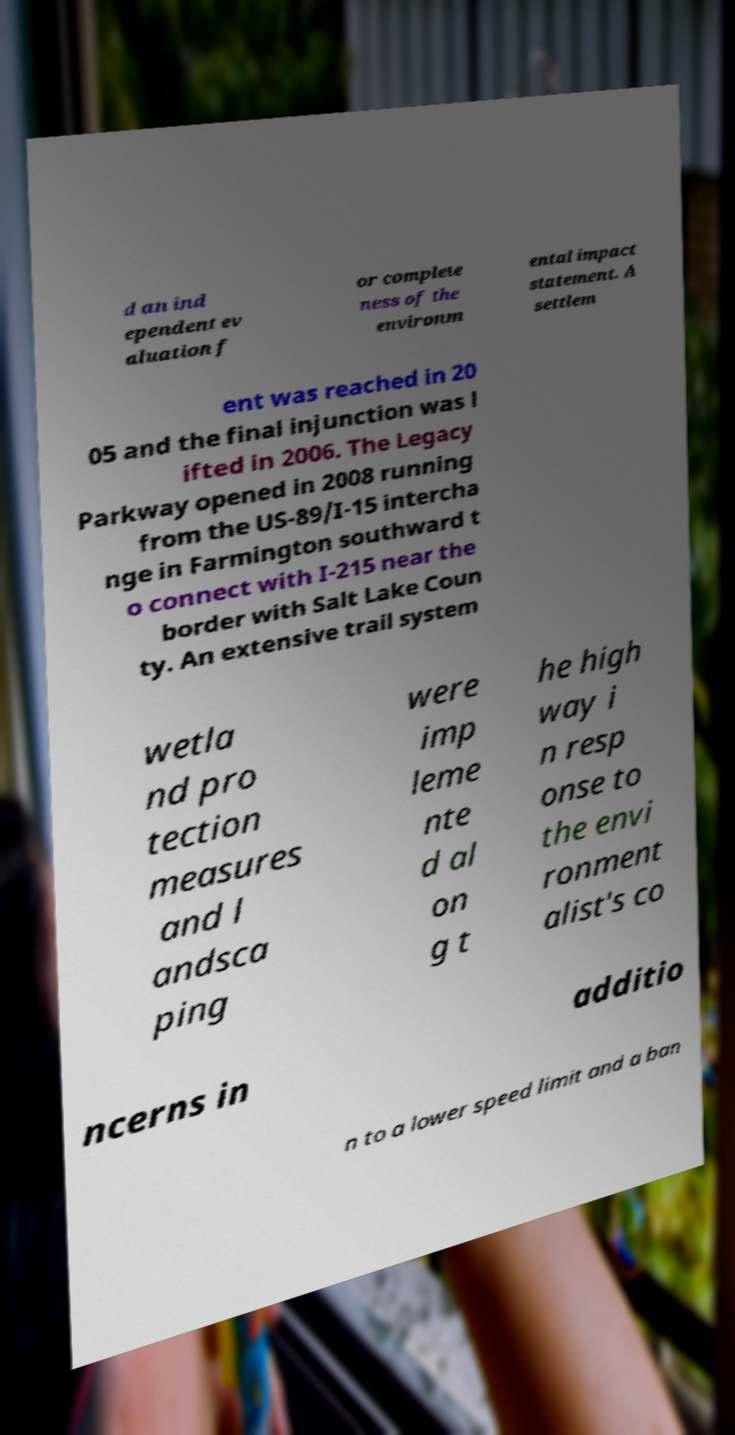Can you accurately transcribe the text from the provided image for me? d an ind ependent ev aluation f or complete ness of the environm ental impact statement. A settlem ent was reached in 20 05 and the final injunction was l ifted in 2006. The Legacy Parkway opened in 2008 running from the US-89/I-15 intercha nge in Farmington southward t o connect with I-215 near the border with Salt Lake Coun ty. An extensive trail system wetla nd pro tection measures and l andsca ping were imp leme nte d al on g t he high way i n resp onse to the envi ronment alist's co ncerns in additio n to a lower speed limit and a ban 